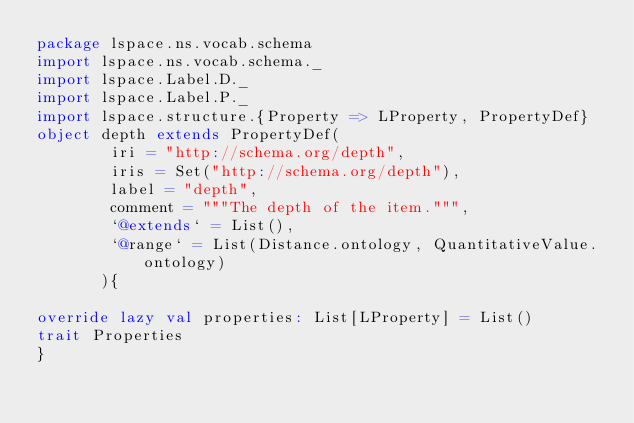Convert code to text. <code><loc_0><loc_0><loc_500><loc_500><_Scala_>package lspace.ns.vocab.schema
import lspace.ns.vocab.schema._
import lspace.Label.D._
import lspace.Label.P._
import lspace.structure.{Property => LProperty, PropertyDef}
object depth extends PropertyDef(
        iri = "http://schema.org/depth",
        iris = Set("http://schema.org/depth"),
        label = "depth",
        comment = """The depth of the item.""",
        `@extends` = List(),
        `@range` = List(Distance.ontology, QuantitativeValue.ontology)
       ){

override lazy val properties: List[LProperty] = List()
trait Properties 
}</code> 